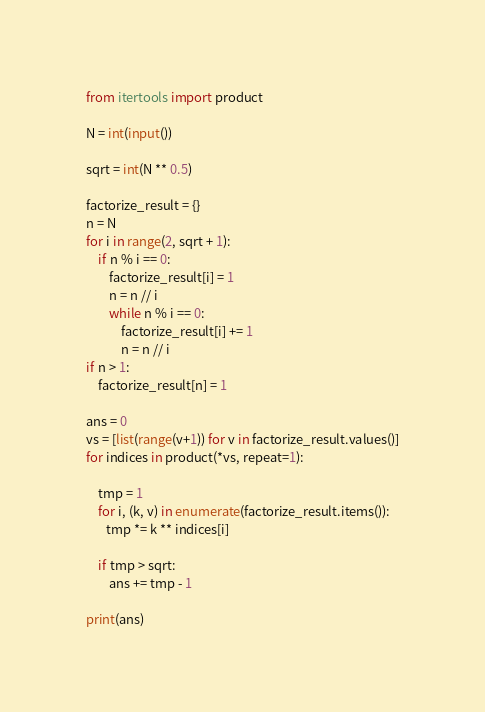Convert code to text. <code><loc_0><loc_0><loc_500><loc_500><_Python_>
from itertools import product

N = int(input())

sqrt = int(N ** 0.5)

factorize_result = {}
n = N
for i in range(2, sqrt + 1):
    if n % i == 0:
        factorize_result[i] = 1
        n = n // i
        while n % i == 0:
            factorize_result[i] += 1
            n = n // i
if n > 1:
    factorize_result[n] = 1

ans = 0
vs = [list(range(v+1)) for v in factorize_result.values()]
for indices in product(*vs, repeat=1):

    tmp = 1
    for i, (k, v) in enumerate(factorize_result.items()):
       tmp *= k ** indices[i]

    if tmp > sqrt:
        ans += tmp - 1

print(ans)





</code> 